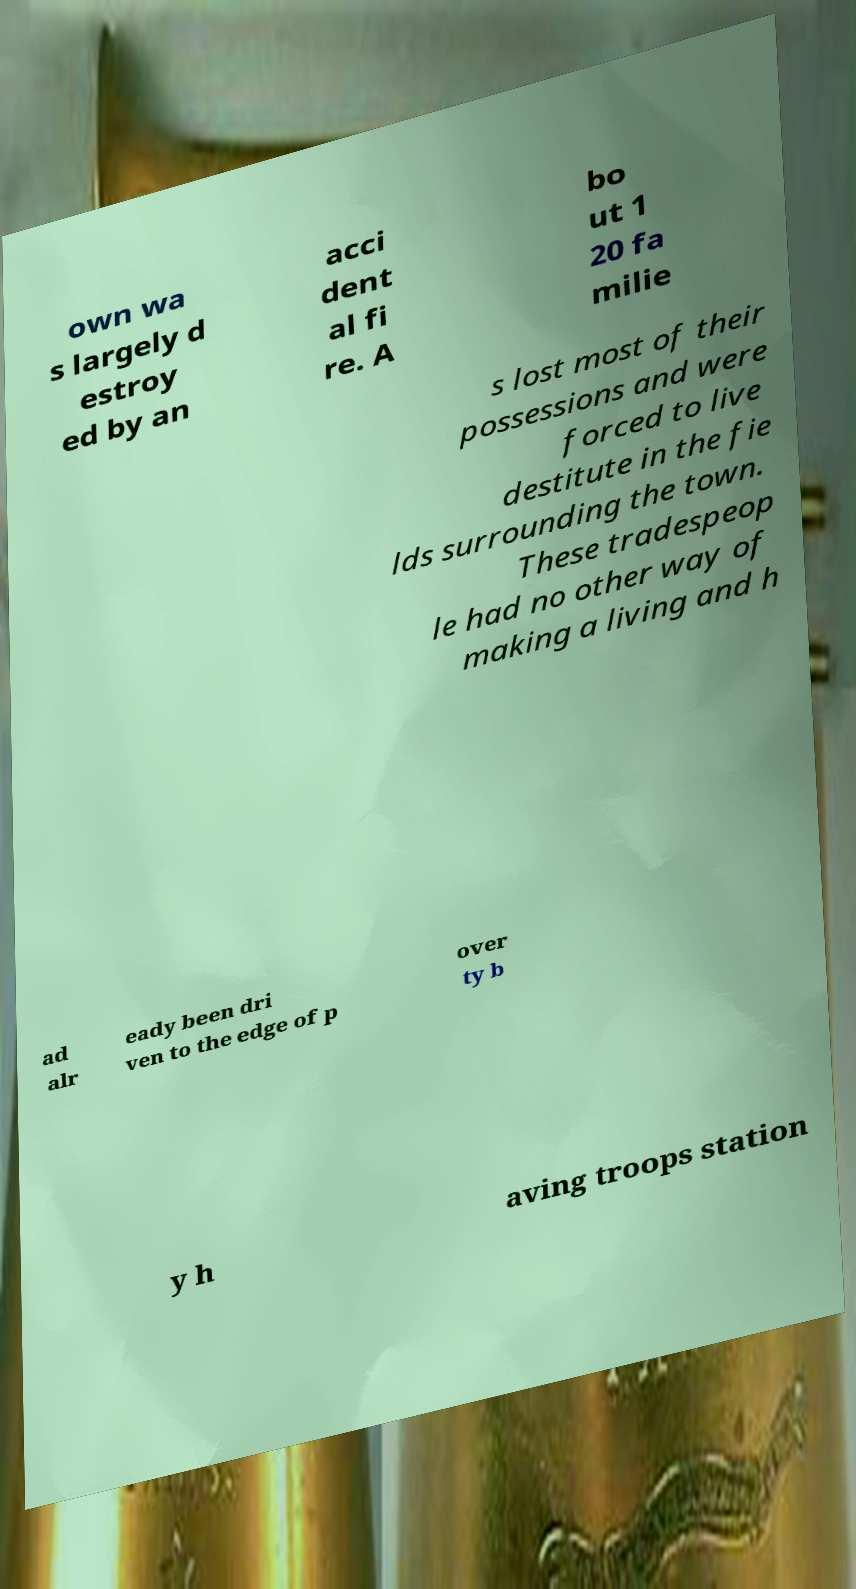There's text embedded in this image that I need extracted. Can you transcribe it verbatim? own wa s largely d estroy ed by an acci dent al fi re. A bo ut 1 20 fa milie s lost most of their possessions and were forced to live destitute in the fie lds surrounding the town. These tradespeop le had no other way of making a living and h ad alr eady been dri ven to the edge of p over ty b y h aving troops station 